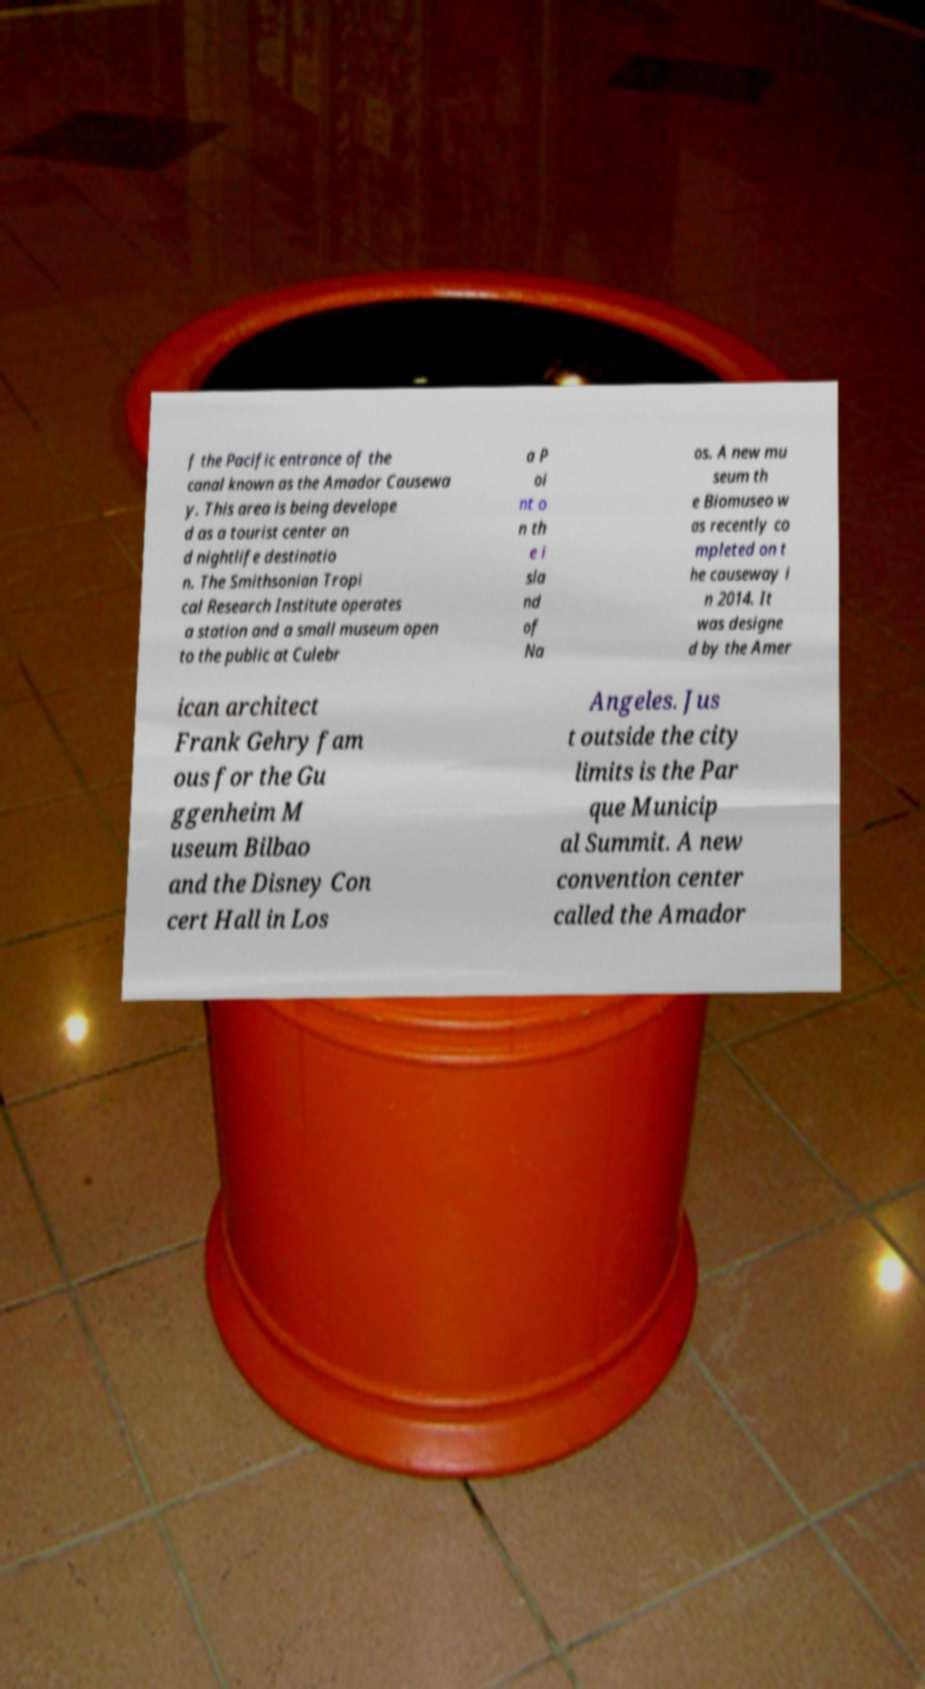Can you accurately transcribe the text from the provided image for me? f the Pacific entrance of the canal known as the Amador Causewa y. This area is being develope d as a tourist center an d nightlife destinatio n. The Smithsonian Tropi cal Research Institute operates a station and a small museum open to the public at Culebr a P oi nt o n th e i sla nd of Na os. A new mu seum th e Biomuseo w as recently co mpleted on t he causeway i n 2014. It was designe d by the Amer ican architect Frank Gehry fam ous for the Gu ggenheim M useum Bilbao and the Disney Con cert Hall in Los Angeles. Jus t outside the city limits is the Par que Municip al Summit. A new convention center called the Amador 